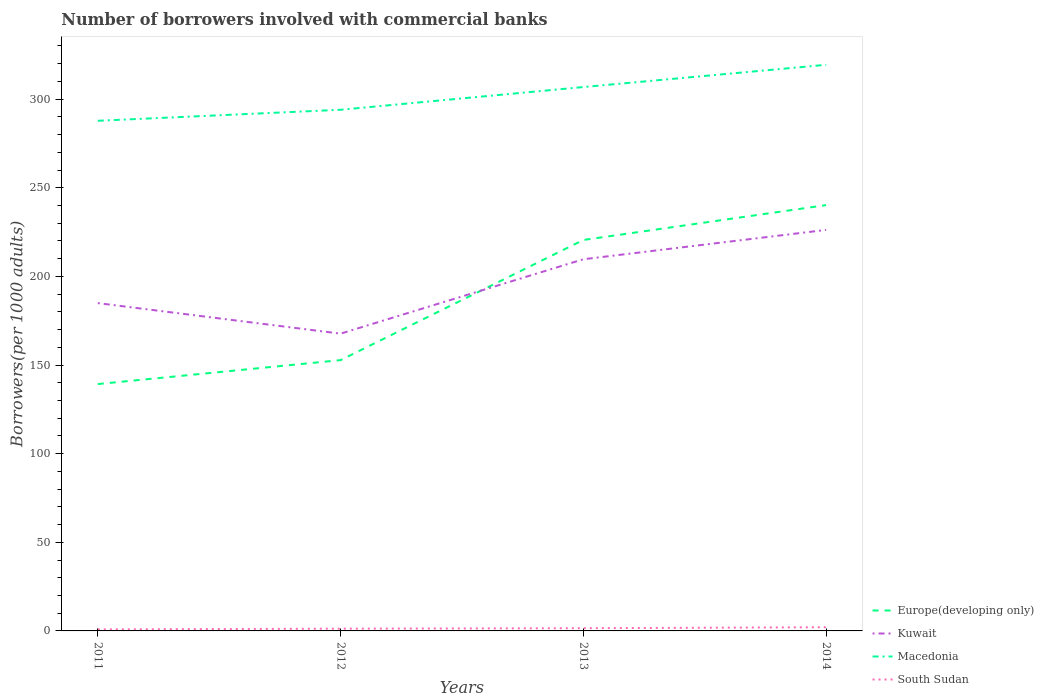Does the line corresponding to Kuwait intersect with the line corresponding to Macedonia?
Ensure brevity in your answer.  No. Across all years, what is the maximum number of borrowers involved with commercial banks in Macedonia?
Your response must be concise. 287.81. In which year was the number of borrowers involved with commercial banks in Europe(developing only) maximum?
Give a very brief answer. 2011. What is the total number of borrowers involved with commercial banks in South Sudan in the graph?
Your answer should be very brief. -0.54. What is the difference between the highest and the second highest number of borrowers involved with commercial banks in South Sudan?
Provide a succinct answer. 1.21. How many lines are there?
Offer a very short reply. 4. How many years are there in the graph?
Keep it short and to the point. 4. What is the difference between two consecutive major ticks on the Y-axis?
Offer a terse response. 50. Are the values on the major ticks of Y-axis written in scientific E-notation?
Keep it short and to the point. No. Does the graph contain any zero values?
Your answer should be very brief. No. Where does the legend appear in the graph?
Your answer should be compact. Bottom right. How many legend labels are there?
Offer a very short reply. 4. What is the title of the graph?
Ensure brevity in your answer.  Number of borrowers involved with commercial banks. Does "South Asia" appear as one of the legend labels in the graph?
Your response must be concise. No. What is the label or title of the X-axis?
Keep it short and to the point. Years. What is the label or title of the Y-axis?
Make the answer very short. Borrowers(per 1000 adults). What is the Borrowers(per 1000 adults) in Europe(developing only) in 2011?
Give a very brief answer. 139.27. What is the Borrowers(per 1000 adults) of Kuwait in 2011?
Give a very brief answer. 184.94. What is the Borrowers(per 1000 adults) in Macedonia in 2011?
Ensure brevity in your answer.  287.81. What is the Borrowers(per 1000 adults) of South Sudan in 2011?
Offer a terse response. 0.86. What is the Borrowers(per 1000 adults) of Europe(developing only) in 2012?
Provide a succinct answer. 152.78. What is the Borrowers(per 1000 adults) of Kuwait in 2012?
Offer a terse response. 167.71. What is the Borrowers(per 1000 adults) in Macedonia in 2012?
Ensure brevity in your answer.  294.02. What is the Borrowers(per 1000 adults) in South Sudan in 2012?
Make the answer very short. 1.27. What is the Borrowers(per 1000 adults) in Europe(developing only) in 2013?
Provide a short and direct response. 220.56. What is the Borrowers(per 1000 adults) of Kuwait in 2013?
Offer a very short reply. 209.68. What is the Borrowers(per 1000 adults) in Macedonia in 2013?
Offer a very short reply. 306.84. What is the Borrowers(per 1000 adults) of South Sudan in 2013?
Give a very brief answer. 1.53. What is the Borrowers(per 1000 adults) in Europe(developing only) in 2014?
Keep it short and to the point. 240.23. What is the Borrowers(per 1000 adults) in Kuwait in 2014?
Give a very brief answer. 226.24. What is the Borrowers(per 1000 adults) of Macedonia in 2014?
Make the answer very short. 319.39. What is the Borrowers(per 1000 adults) of South Sudan in 2014?
Give a very brief answer. 2.07. Across all years, what is the maximum Borrowers(per 1000 adults) of Europe(developing only)?
Offer a very short reply. 240.23. Across all years, what is the maximum Borrowers(per 1000 adults) in Kuwait?
Give a very brief answer. 226.24. Across all years, what is the maximum Borrowers(per 1000 adults) in Macedonia?
Your answer should be very brief. 319.39. Across all years, what is the maximum Borrowers(per 1000 adults) in South Sudan?
Your answer should be very brief. 2.07. Across all years, what is the minimum Borrowers(per 1000 adults) of Europe(developing only)?
Your answer should be compact. 139.27. Across all years, what is the minimum Borrowers(per 1000 adults) of Kuwait?
Ensure brevity in your answer.  167.71. Across all years, what is the minimum Borrowers(per 1000 adults) in Macedonia?
Give a very brief answer. 287.81. Across all years, what is the minimum Borrowers(per 1000 adults) of South Sudan?
Make the answer very short. 0.86. What is the total Borrowers(per 1000 adults) of Europe(developing only) in the graph?
Your answer should be compact. 752.84. What is the total Borrowers(per 1000 adults) of Kuwait in the graph?
Provide a succinct answer. 788.57. What is the total Borrowers(per 1000 adults) in Macedonia in the graph?
Your response must be concise. 1208.05. What is the total Borrowers(per 1000 adults) of South Sudan in the graph?
Your answer should be compact. 5.73. What is the difference between the Borrowers(per 1000 adults) in Europe(developing only) in 2011 and that in 2012?
Make the answer very short. -13.51. What is the difference between the Borrowers(per 1000 adults) in Kuwait in 2011 and that in 2012?
Give a very brief answer. 17.23. What is the difference between the Borrowers(per 1000 adults) of Macedonia in 2011 and that in 2012?
Provide a short and direct response. -6.21. What is the difference between the Borrowers(per 1000 adults) in South Sudan in 2011 and that in 2012?
Your answer should be compact. -0.41. What is the difference between the Borrowers(per 1000 adults) of Europe(developing only) in 2011 and that in 2013?
Make the answer very short. -81.3. What is the difference between the Borrowers(per 1000 adults) of Kuwait in 2011 and that in 2013?
Ensure brevity in your answer.  -24.73. What is the difference between the Borrowers(per 1000 adults) in Macedonia in 2011 and that in 2013?
Your response must be concise. -19.03. What is the difference between the Borrowers(per 1000 adults) in South Sudan in 2011 and that in 2013?
Give a very brief answer. -0.67. What is the difference between the Borrowers(per 1000 adults) in Europe(developing only) in 2011 and that in 2014?
Your answer should be compact. -100.97. What is the difference between the Borrowers(per 1000 adults) in Kuwait in 2011 and that in 2014?
Keep it short and to the point. -41.3. What is the difference between the Borrowers(per 1000 adults) of Macedonia in 2011 and that in 2014?
Ensure brevity in your answer.  -31.58. What is the difference between the Borrowers(per 1000 adults) of South Sudan in 2011 and that in 2014?
Ensure brevity in your answer.  -1.21. What is the difference between the Borrowers(per 1000 adults) of Europe(developing only) in 2012 and that in 2013?
Give a very brief answer. -67.78. What is the difference between the Borrowers(per 1000 adults) in Kuwait in 2012 and that in 2013?
Make the answer very short. -41.96. What is the difference between the Borrowers(per 1000 adults) of Macedonia in 2012 and that in 2013?
Your response must be concise. -12.82. What is the difference between the Borrowers(per 1000 adults) of South Sudan in 2012 and that in 2013?
Offer a very short reply. -0.26. What is the difference between the Borrowers(per 1000 adults) of Europe(developing only) in 2012 and that in 2014?
Offer a terse response. -87.45. What is the difference between the Borrowers(per 1000 adults) of Kuwait in 2012 and that in 2014?
Ensure brevity in your answer.  -58.53. What is the difference between the Borrowers(per 1000 adults) in Macedonia in 2012 and that in 2014?
Provide a succinct answer. -25.37. What is the difference between the Borrowers(per 1000 adults) in South Sudan in 2012 and that in 2014?
Your answer should be very brief. -0.8. What is the difference between the Borrowers(per 1000 adults) in Europe(developing only) in 2013 and that in 2014?
Your answer should be compact. -19.67. What is the difference between the Borrowers(per 1000 adults) of Kuwait in 2013 and that in 2014?
Offer a terse response. -16.57. What is the difference between the Borrowers(per 1000 adults) of Macedonia in 2013 and that in 2014?
Your answer should be compact. -12.55. What is the difference between the Borrowers(per 1000 adults) of South Sudan in 2013 and that in 2014?
Your response must be concise. -0.54. What is the difference between the Borrowers(per 1000 adults) of Europe(developing only) in 2011 and the Borrowers(per 1000 adults) of Kuwait in 2012?
Offer a terse response. -28.45. What is the difference between the Borrowers(per 1000 adults) in Europe(developing only) in 2011 and the Borrowers(per 1000 adults) in Macedonia in 2012?
Your response must be concise. -154.75. What is the difference between the Borrowers(per 1000 adults) in Europe(developing only) in 2011 and the Borrowers(per 1000 adults) in South Sudan in 2012?
Make the answer very short. 138. What is the difference between the Borrowers(per 1000 adults) of Kuwait in 2011 and the Borrowers(per 1000 adults) of Macedonia in 2012?
Your answer should be compact. -109.08. What is the difference between the Borrowers(per 1000 adults) of Kuwait in 2011 and the Borrowers(per 1000 adults) of South Sudan in 2012?
Offer a very short reply. 183.67. What is the difference between the Borrowers(per 1000 adults) of Macedonia in 2011 and the Borrowers(per 1000 adults) of South Sudan in 2012?
Offer a terse response. 286.54. What is the difference between the Borrowers(per 1000 adults) of Europe(developing only) in 2011 and the Borrowers(per 1000 adults) of Kuwait in 2013?
Provide a succinct answer. -70.41. What is the difference between the Borrowers(per 1000 adults) of Europe(developing only) in 2011 and the Borrowers(per 1000 adults) of Macedonia in 2013?
Ensure brevity in your answer.  -167.57. What is the difference between the Borrowers(per 1000 adults) of Europe(developing only) in 2011 and the Borrowers(per 1000 adults) of South Sudan in 2013?
Your answer should be very brief. 137.74. What is the difference between the Borrowers(per 1000 adults) of Kuwait in 2011 and the Borrowers(per 1000 adults) of Macedonia in 2013?
Offer a terse response. -121.9. What is the difference between the Borrowers(per 1000 adults) of Kuwait in 2011 and the Borrowers(per 1000 adults) of South Sudan in 2013?
Offer a terse response. 183.41. What is the difference between the Borrowers(per 1000 adults) in Macedonia in 2011 and the Borrowers(per 1000 adults) in South Sudan in 2013?
Give a very brief answer. 286.28. What is the difference between the Borrowers(per 1000 adults) of Europe(developing only) in 2011 and the Borrowers(per 1000 adults) of Kuwait in 2014?
Keep it short and to the point. -86.97. What is the difference between the Borrowers(per 1000 adults) in Europe(developing only) in 2011 and the Borrowers(per 1000 adults) in Macedonia in 2014?
Offer a very short reply. -180.12. What is the difference between the Borrowers(per 1000 adults) of Europe(developing only) in 2011 and the Borrowers(per 1000 adults) of South Sudan in 2014?
Your answer should be very brief. 137.2. What is the difference between the Borrowers(per 1000 adults) in Kuwait in 2011 and the Borrowers(per 1000 adults) in Macedonia in 2014?
Make the answer very short. -134.44. What is the difference between the Borrowers(per 1000 adults) in Kuwait in 2011 and the Borrowers(per 1000 adults) in South Sudan in 2014?
Your answer should be compact. 182.87. What is the difference between the Borrowers(per 1000 adults) in Macedonia in 2011 and the Borrowers(per 1000 adults) in South Sudan in 2014?
Offer a very short reply. 285.74. What is the difference between the Borrowers(per 1000 adults) in Europe(developing only) in 2012 and the Borrowers(per 1000 adults) in Kuwait in 2013?
Keep it short and to the point. -56.9. What is the difference between the Borrowers(per 1000 adults) of Europe(developing only) in 2012 and the Borrowers(per 1000 adults) of Macedonia in 2013?
Provide a short and direct response. -154.06. What is the difference between the Borrowers(per 1000 adults) of Europe(developing only) in 2012 and the Borrowers(per 1000 adults) of South Sudan in 2013?
Ensure brevity in your answer.  151.25. What is the difference between the Borrowers(per 1000 adults) in Kuwait in 2012 and the Borrowers(per 1000 adults) in Macedonia in 2013?
Make the answer very short. -139.13. What is the difference between the Borrowers(per 1000 adults) in Kuwait in 2012 and the Borrowers(per 1000 adults) in South Sudan in 2013?
Make the answer very short. 166.18. What is the difference between the Borrowers(per 1000 adults) of Macedonia in 2012 and the Borrowers(per 1000 adults) of South Sudan in 2013?
Give a very brief answer. 292.49. What is the difference between the Borrowers(per 1000 adults) in Europe(developing only) in 2012 and the Borrowers(per 1000 adults) in Kuwait in 2014?
Make the answer very short. -73.46. What is the difference between the Borrowers(per 1000 adults) in Europe(developing only) in 2012 and the Borrowers(per 1000 adults) in Macedonia in 2014?
Provide a succinct answer. -166.6. What is the difference between the Borrowers(per 1000 adults) in Europe(developing only) in 2012 and the Borrowers(per 1000 adults) in South Sudan in 2014?
Make the answer very short. 150.71. What is the difference between the Borrowers(per 1000 adults) of Kuwait in 2012 and the Borrowers(per 1000 adults) of Macedonia in 2014?
Make the answer very short. -151.67. What is the difference between the Borrowers(per 1000 adults) of Kuwait in 2012 and the Borrowers(per 1000 adults) of South Sudan in 2014?
Your answer should be compact. 165.64. What is the difference between the Borrowers(per 1000 adults) in Macedonia in 2012 and the Borrowers(per 1000 adults) in South Sudan in 2014?
Give a very brief answer. 291.95. What is the difference between the Borrowers(per 1000 adults) of Europe(developing only) in 2013 and the Borrowers(per 1000 adults) of Kuwait in 2014?
Your answer should be compact. -5.68. What is the difference between the Borrowers(per 1000 adults) of Europe(developing only) in 2013 and the Borrowers(per 1000 adults) of Macedonia in 2014?
Offer a very short reply. -98.82. What is the difference between the Borrowers(per 1000 adults) in Europe(developing only) in 2013 and the Borrowers(per 1000 adults) in South Sudan in 2014?
Your response must be concise. 218.49. What is the difference between the Borrowers(per 1000 adults) of Kuwait in 2013 and the Borrowers(per 1000 adults) of Macedonia in 2014?
Offer a terse response. -109.71. What is the difference between the Borrowers(per 1000 adults) of Kuwait in 2013 and the Borrowers(per 1000 adults) of South Sudan in 2014?
Ensure brevity in your answer.  207.61. What is the difference between the Borrowers(per 1000 adults) in Macedonia in 2013 and the Borrowers(per 1000 adults) in South Sudan in 2014?
Provide a short and direct response. 304.77. What is the average Borrowers(per 1000 adults) in Europe(developing only) per year?
Provide a short and direct response. 188.21. What is the average Borrowers(per 1000 adults) in Kuwait per year?
Make the answer very short. 197.14. What is the average Borrowers(per 1000 adults) in Macedonia per year?
Keep it short and to the point. 302.01. What is the average Borrowers(per 1000 adults) of South Sudan per year?
Your response must be concise. 1.43. In the year 2011, what is the difference between the Borrowers(per 1000 adults) in Europe(developing only) and Borrowers(per 1000 adults) in Kuwait?
Keep it short and to the point. -45.68. In the year 2011, what is the difference between the Borrowers(per 1000 adults) in Europe(developing only) and Borrowers(per 1000 adults) in Macedonia?
Offer a very short reply. -148.54. In the year 2011, what is the difference between the Borrowers(per 1000 adults) of Europe(developing only) and Borrowers(per 1000 adults) of South Sudan?
Provide a succinct answer. 138.41. In the year 2011, what is the difference between the Borrowers(per 1000 adults) of Kuwait and Borrowers(per 1000 adults) of Macedonia?
Keep it short and to the point. -102.87. In the year 2011, what is the difference between the Borrowers(per 1000 adults) of Kuwait and Borrowers(per 1000 adults) of South Sudan?
Keep it short and to the point. 184.08. In the year 2011, what is the difference between the Borrowers(per 1000 adults) in Macedonia and Borrowers(per 1000 adults) in South Sudan?
Give a very brief answer. 286.95. In the year 2012, what is the difference between the Borrowers(per 1000 adults) of Europe(developing only) and Borrowers(per 1000 adults) of Kuwait?
Your answer should be very brief. -14.93. In the year 2012, what is the difference between the Borrowers(per 1000 adults) in Europe(developing only) and Borrowers(per 1000 adults) in Macedonia?
Your answer should be compact. -141.24. In the year 2012, what is the difference between the Borrowers(per 1000 adults) of Europe(developing only) and Borrowers(per 1000 adults) of South Sudan?
Your answer should be very brief. 151.51. In the year 2012, what is the difference between the Borrowers(per 1000 adults) of Kuwait and Borrowers(per 1000 adults) of Macedonia?
Give a very brief answer. -126.31. In the year 2012, what is the difference between the Borrowers(per 1000 adults) in Kuwait and Borrowers(per 1000 adults) in South Sudan?
Offer a terse response. 166.44. In the year 2012, what is the difference between the Borrowers(per 1000 adults) of Macedonia and Borrowers(per 1000 adults) of South Sudan?
Your response must be concise. 292.75. In the year 2013, what is the difference between the Borrowers(per 1000 adults) of Europe(developing only) and Borrowers(per 1000 adults) of Kuwait?
Make the answer very short. 10.89. In the year 2013, what is the difference between the Borrowers(per 1000 adults) in Europe(developing only) and Borrowers(per 1000 adults) in Macedonia?
Your answer should be compact. -86.28. In the year 2013, what is the difference between the Borrowers(per 1000 adults) of Europe(developing only) and Borrowers(per 1000 adults) of South Sudan?
Offer a very short reply. 219.03. In the year 2013, what is the difference between the Borrowers(per 1000 adults) of Kuwait and Borrowers(per 1000 adults) of Macedonia?
Provide a succinct answer. -97.16. In the year 2013, what is the difference between the Borrowers(per 1000 adults) of Kuwait and Borrowers(per 1000 adults) of South Sudan?
Your answer should be compact. 208.15. In the year 2013, what is the difference between the Borrowers(per 1000 adults) of Macedonia and Borrowers(per 1000 adults) of South Sudan?
Keep it short and to the point. 305.31. In the year 2014, what is the difference between the Borrowers(per 1000 adults) of Europe(developing only) and Borrowers(per 1000 adults) of Kuwait?
Keep it short and to the point. 13.99. In the year 2014, what is the difference between the Borrowers(per 1000 adults) of Europe(developing only) and Borrowers(per 1000 adults) of Macedonia?
Make the answer very short. -79.15. In the year 2014, what is the difference between the Borrowers(per 1000 adults) of Europe(developing only) and Borrowers(per 1000 adults) of South Sudan?
Provide a succinct answer. 238.16. In the year 2014, what is the difference between the Borrowers(per 1000 adults) of Kuwait and Borrowers(per 1000 adults) of Macedonia?
Give a very brief answer. -93.14. In the year 2014, what is the difference between the Borrowers(per 1000 adults) of Kuwait and Borrowers(per 1000 adults) of South Sudan?
Make the answer very short. 224.17. In the year 2014, what is the difference between the Borrowers(per 1000 adults) in Macedonia and Borrowers(per 1000 adults) in South Sudan?
Keep it short and to the point. 317.32. What is the ratio of the Borrowers(per 1000 adults) of Europe(developing only) in 2011 to that in 2012?
Provide a short and direct response. 0.91. What is the ratio of the Borrowers(per 1000 adults) of Kuwait in 2011 to that in 2012?
Provide a succinct answer. 1.1. What is the ratio of the Borrowers(per 1000 adults) in Macedonia in 2011 to that in 2012?
Your answer should be very brief. 0.98. What is the ratio of the Borrowers(per 1000 adults) of South Sudan in 2011 to that in 2012?
Your answer should be compact. 0.68. What is the ratio of the Borrowers(per 1000 adults) of Europe(developing only) in 2011 to that in 2013?
Your answer should be compact. 0.63. What is the ratio of the Borrowers(per 1000 adults) of Kuwait in 2011 to that in 2013?
Your answer should be compact. 0.88. What is the ratio of the Borrowers(per 1000 adults) of Macedonia in 2011 to that in 2013?
Ensure brevity in your answer.  0.94. What is the ratio of the Borrowers(per 1000 adults) of South Sudan in 2011 to that in 2013?
Offer a terse response. 0.56. What is the ratio of the Borrowers(per 1000 adults) of Europe(developing only) in 2011 to that in 2014?
Offer a terse response. 0.58. What is the ratio of the Borrowers(per 1000 adults) in Kuwait in 2011 to that in 2014?
Ensure brevity in your answer.  0.82. What is the ratio of the Borrowers(per 1000 adults) in Macedonia in 2011 to that in 2014?
Ensure brevity in your answer.  0.9. What is the ratio of the Borrowers(per 1000 adults) of South Sudan in 2011 to that in 2014?
Provide a short and direct response. 0.42. What is the ratio of the Borrowers(per 1000 adults) of Europe(developing only) in 2012 to that in 2013?
Offer a terse response. 0.69. What is the ratio of the Borrowers(per 1000 adults) in Kuwait in 2012 to that in 2013?
Your answer should be very brief. 0.8. What is the ratio of the Borrowers(per 1000 adults) of Macedonia in 2012 to that in 2013?
Ensure brevity in your answer.  0.96. What is the ratio of the Borrowers(per 1000 adults) in South Sudan in 2012 to that in 2013?
Your response must be concise. 0.83. What is the ratio of the Borrowers(per 1000 adults) of Europe(developing only) in 2012 to that in 2014?
Your response must be concise. 0.64. What is the ratio of the Borrowers(per 1000 adults) in Kuwait in 2012 to that in 2014?
Ensure brevity in your answer.  0.74. What is the ratio of the Borrowers(per 1000 adults) of Macedonia in 2012 to that in 2014?
Keep it short and to the point. 0.92. What is the ratio of the Borrowers(per 1000 adults) in South Sudan in 2012 to that in 2014?
Keep it short and to the point. 0.61. What is the ratio of the Borrowers(per 1000 adults) in Europe(developing only) in 2013 to that in 2014?
Give a very brief answer. 0.92. What is the ratio of the Borrowers(per 1000 adults) of Kuwait in 2013 to that in 2014?
Make the answer very short. 0.93. What is the ratio of the Borrowers(per 1000 adults) in Macedonia in 2013 to that in 2014?
Offer a terse response. 0.96. What is the ratio of the Borrowers(per 1000 adults) in South Sudan in 2013 to that in 2014?
Offer a very short reply. 0.74. What is the difference between the highest and the second highest Borrowers(per 1000 adults) of Europe(developing only)?
Keep it short and to the point. 19.67. What is the difference between the highest and the second highest Borrowers(per 1000 adults) of Kuwait?
Keep it short and to the point. 16.57. What is the difference between the highest and the second highest Borrowers(per 1000 adults) of Macedonia?
Make the answer very short. 12.55. What is the difference between the highest and the second highest Borrowers(per 1000 adults) of South Sudan?
Your response must be concise. 0.54. What is the difference between the highest and the lowest Borrowers(per 1000 adults) in Europe(developing only)?
Give a very brief answer. 100.97. What is the difference between the highest and the lowest Borrowers(per 1000 adults) in Kuwait?
Keep it short and to the point. 58.53. What is the difference between the highest and the lowest Borrowers(per 1000 adults) in Macedonia?
Provide a short and direct response. 31.58. What is the difference between the highest and the lowest Borrowers(per 1000 adults) of South Sudan?
Ensure brevity in your answer.  1.21. 